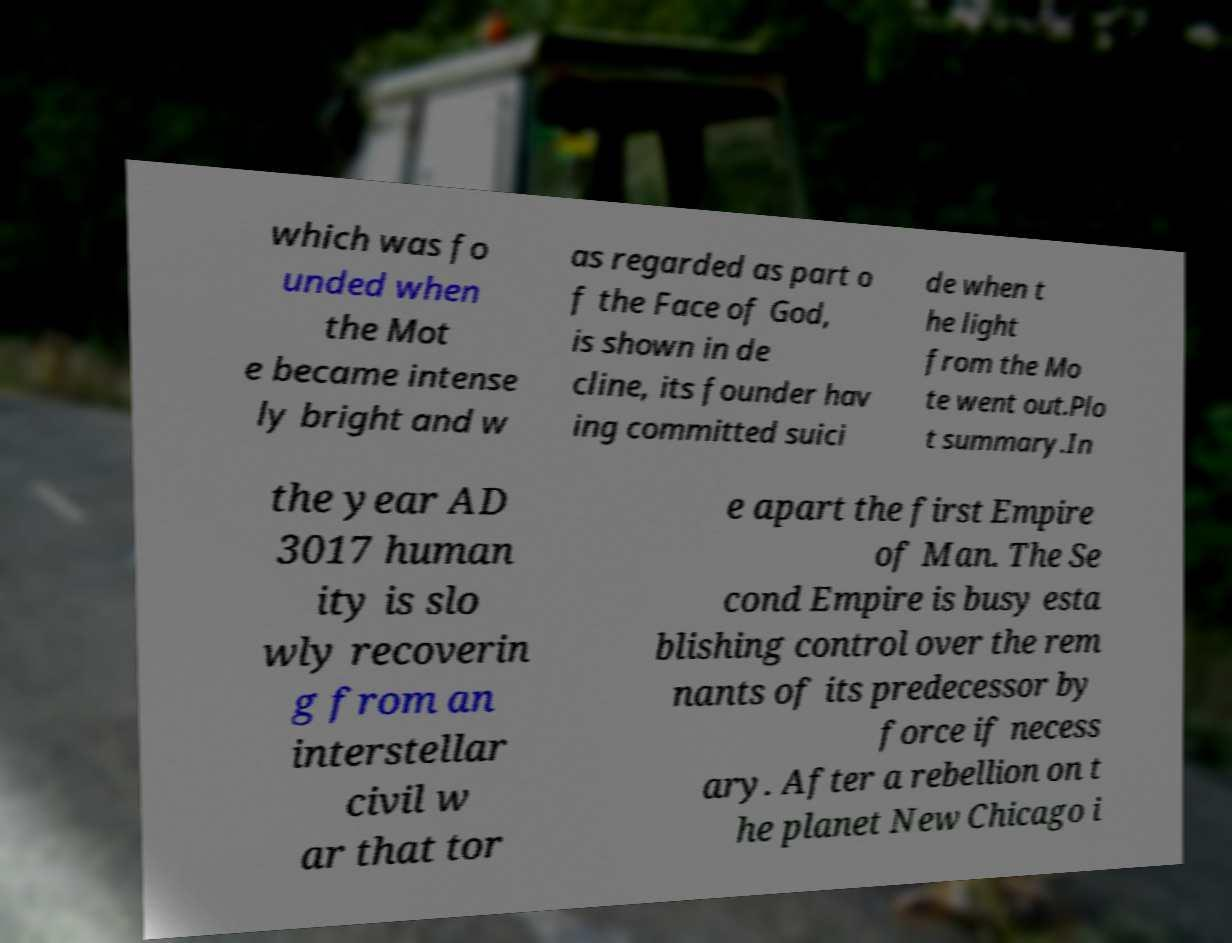Could you extract and type out the text from this image? which was fo unded when the Mot e became intense ly bright and w as regarded as part o f the Face of God, is shown in de cline, its founder hav ing committed suici de when t he light from the Mo te went out.Plo t summary.In the year AD 3017 human ity is slo wly recoverin g from an interstellar civil w ar that tor e apart the first Empire of Man. The Se cond Empire is busy esta blishing control over the rem nants of its predecessor by force if necess ary. After a rebellion on t he planet New Chicago i 